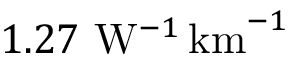<formula> <loc_0><loc_0><loc_500><loc_500>1 . 2 7 W ^ { - 1 } \, k m ^ { - 1 }</formula> 